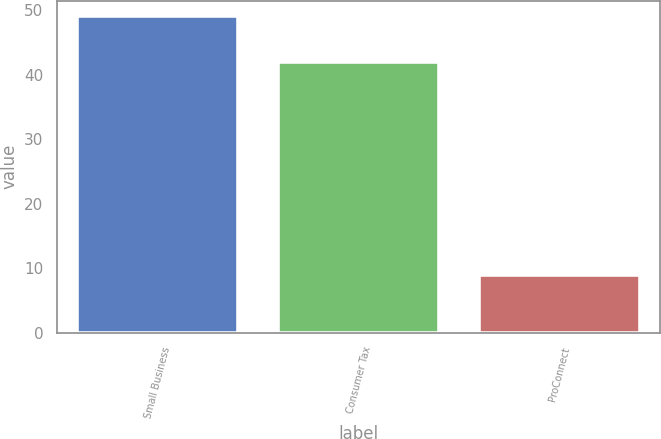<chart> <loc_0><loc_0><loc_500><loc_500><bar_chart><fcel>Small Business<fcel>Consumer Tax<fcel>ProConnect<nl><fcel>49<fcel>42<fcel>9<nl></chart> 